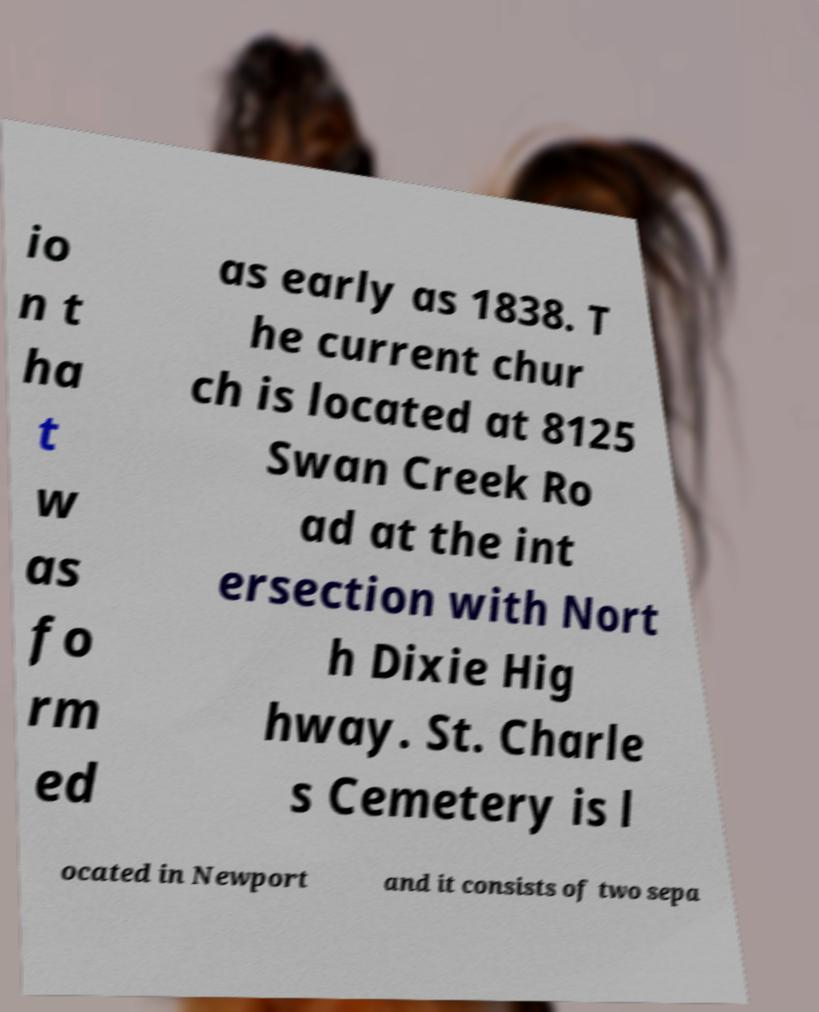Can you read and provide the text displayed in the image?This photo seems to have some interesting text. Can you extract and type it out for me? io n t ha t w as fo rm ed as early as 1838. T he current chur ch is located at 8125 Swan Creek Ro ad at the int ersection with Nort h Dixie Hig hway. St. Charle s Cemetery is l ocated in Newport and it consists of two sepa 